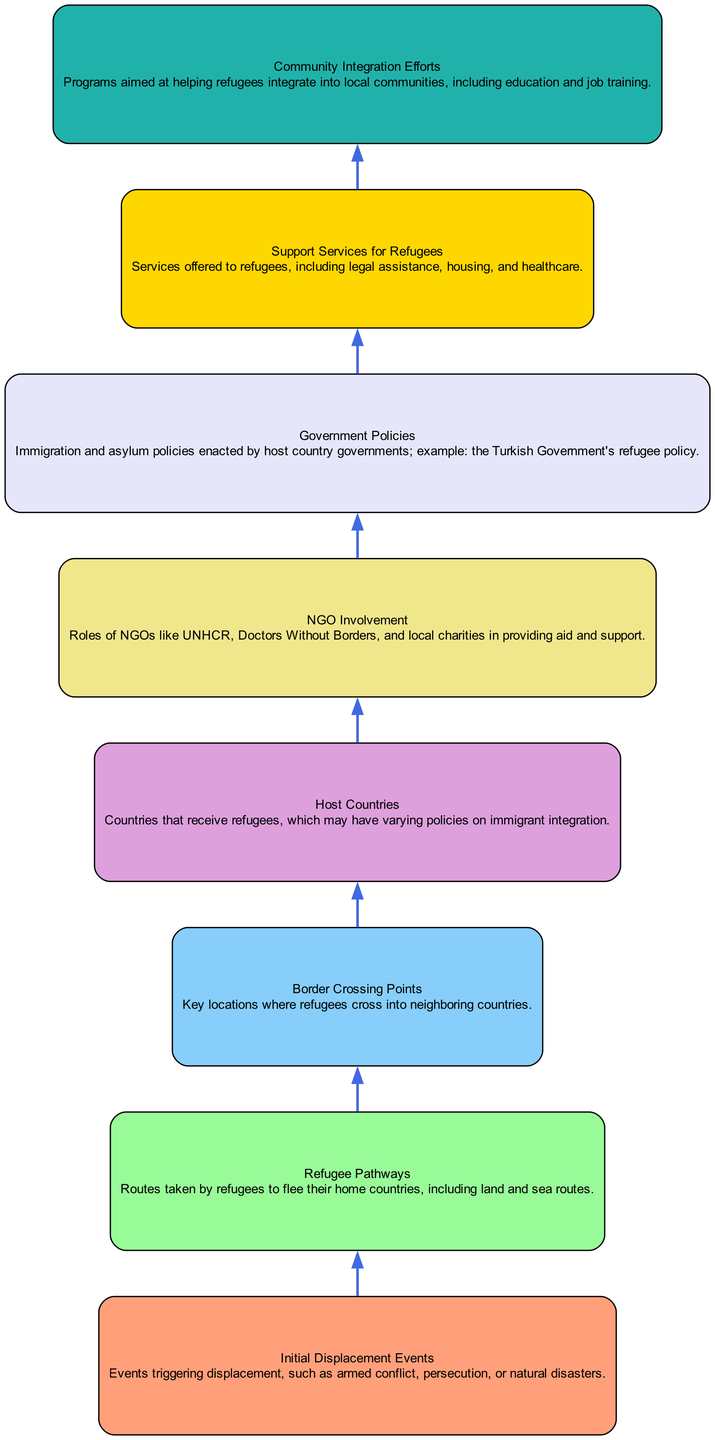What event triggers the flow of displacement in this diagram? The first node in the diagram is "Initial Displacement Events," which signifies that these events such as armed conflict, persecution, or natural disasters trigger the displacement flow.
Answer: Initial Displacement Events How many levels are in the diagram? There are a total of 7 levels indicated by the different steps from initial displacement to community integration efforts. Counting each level shows there are 7 distinct tiers.
Answer: 7 What are the roles of NGOs listed in this diagram? The node "NGO Involvement" specifies the roles of NGOs such as UNHCR, Doctors Without Borders, and local charities in providing aid and support to refugees.
Answer: NGO Involvement Which node follows "Border Crossing Points"? The node addressed after "Border Crossing Points" is "Host Countries," indicating that after refugees cross borders, they enter host countries.
Answer: Host Countries What kind of services is provided to refugees according to this diagram? The node "Support Services for Refugees" outlines the services offered to refugees, including legal assistance, housing, and healthcare.
Answer: Support Services for Refugees What is the connection between "Host Countries" and "Community Integration Efforts"? "Host Countries" leads to "Community Integration Efforts," illustrating that once refugees are in host countries, efforts are made to help them integrate into local communities.
Answer: Community Integration Efforts How does government policy influence refugee support? The diagram indicates that "Government Policies" influence the level of "Support Services for Refugees," as these policies dictate the available assistance provided by the host countries to refugees.
Answer: Support Services for Refugees Which color represents the node for "Initial Displacement Events"? The node for "Initial Displacement Events" is characterized by its color, which is #FFA07A, according to the defined color scheme in the diagram.
Answer: #FFA07A What is the final stage in the flow of this diagram? The last node in the flow is "Community Integration Efforts," indicating this is the ultimate aim for supporting refugees as they settle in host countries.
Answer: Community Integration Efforts 